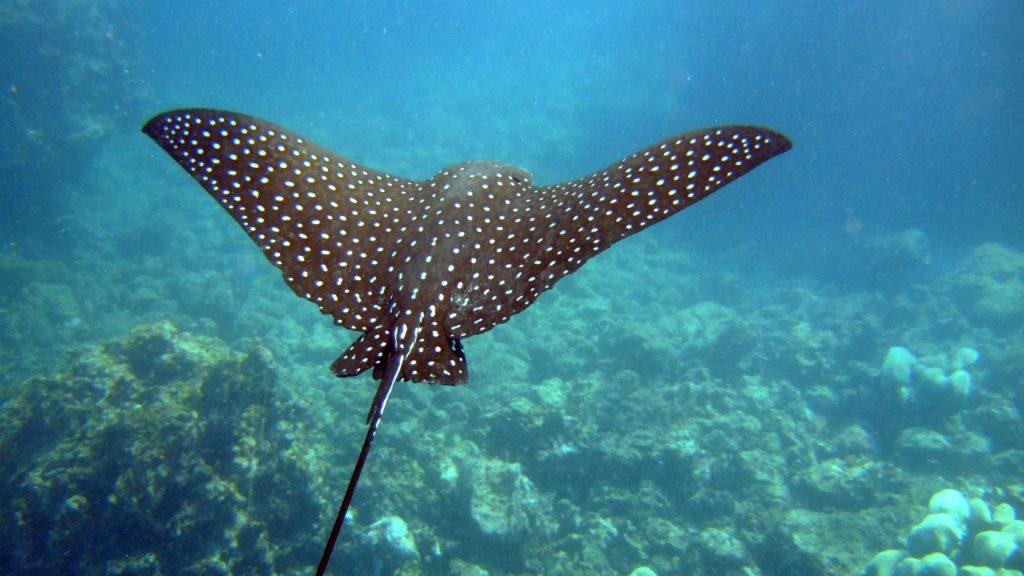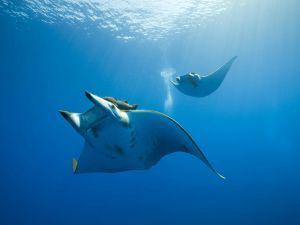The first image is the image on the left, the second image is the image on the right. Examine the images to the left and right. Is the description "a stingray is moving the sandy ocean bottom move while swimming" accurate? Answer yes or no. No. The first image is the image on the left, the second image is the image on the right. Evaluate the accuracy of this statement regarding the images: "The right image features two rays.". Is it true? Answer yes or no. Yes. 